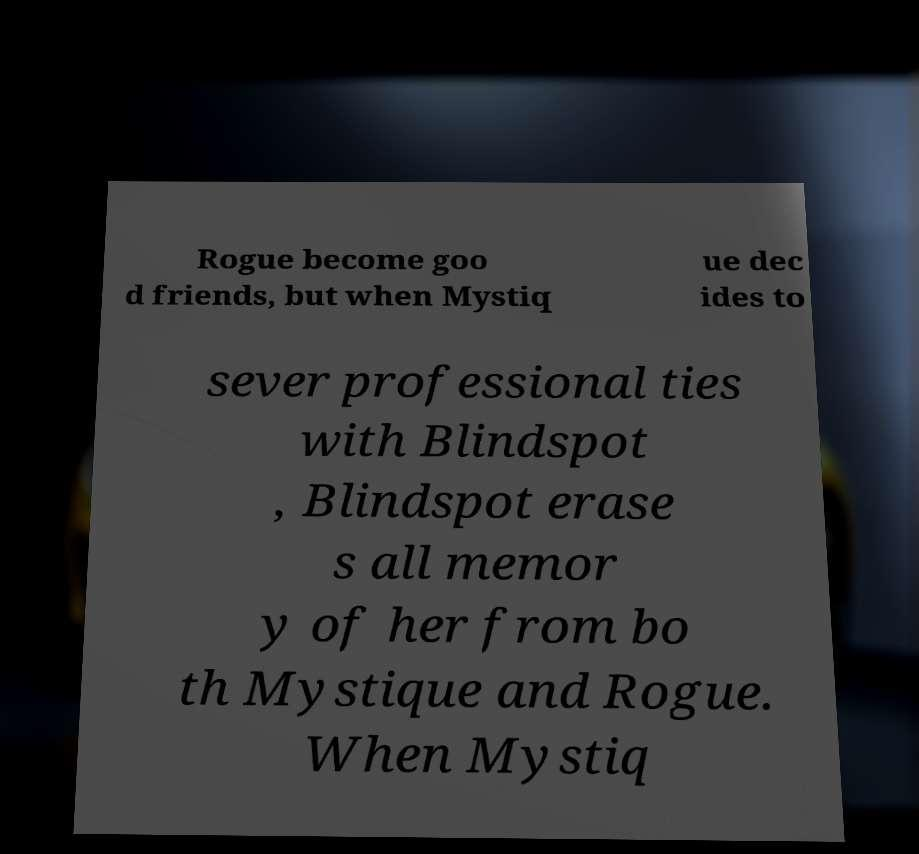I need the written content from this picture converted into text. Can you do that? Rogue become goo d friends, but when Mystiq ue dec ides to sever professional ties with Blindspot , Blindspot erase s all memor y of her from bo th Mystique and Rogue. When Mystiq 